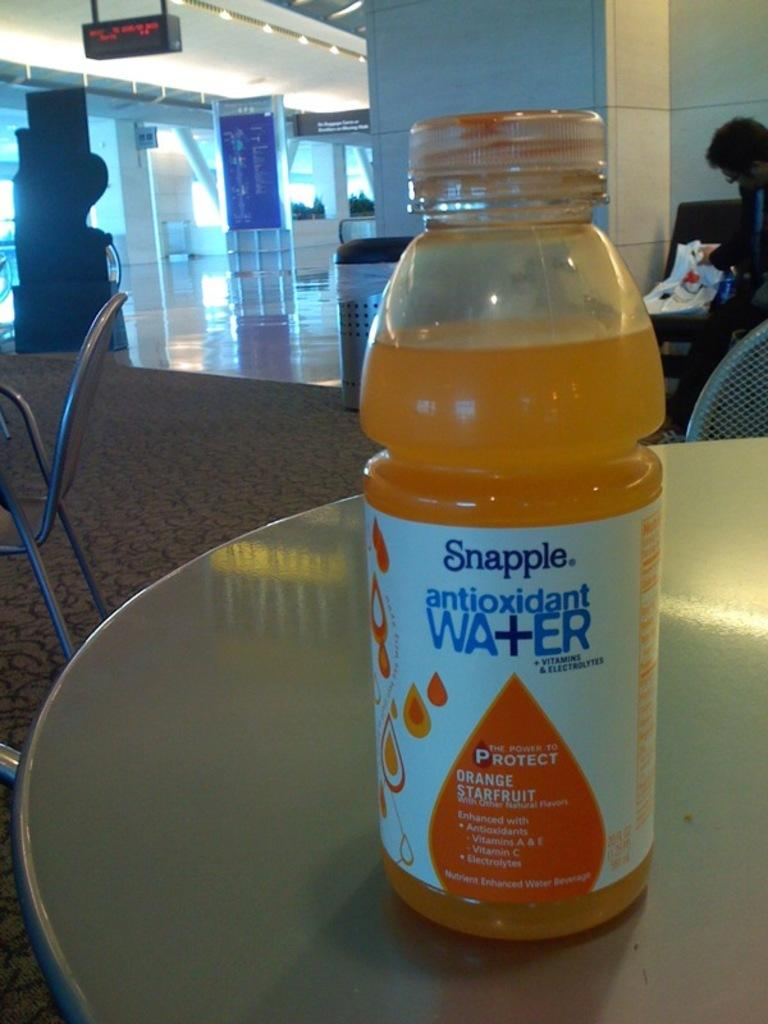<image>
Summarize the visual content of the image. Snapple Antioxidant water sits alone on a table. 